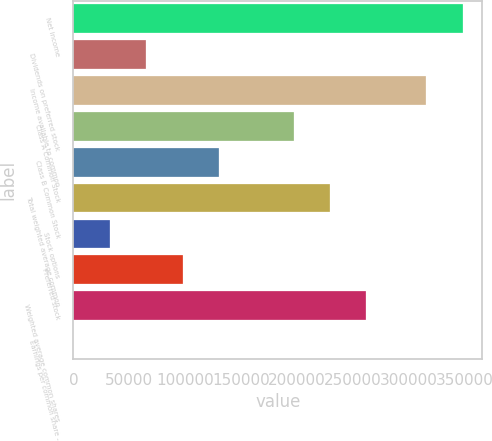Convert chart. <chart><loc_0><loc_0><loc_500><loc_500><bar_chart><fcel>Net income<fcel>Dividends on preferred stock<fcel>Income available to common<fcel>Class A Common Stock<fcel>Class B Common Stock<fcel>Total weighted average common<fcel>Stock options<fcel>Preferred stock<fcel>Weighted average common shares<fcel>Earnings per common share -<nl><fcel>347984<fcel>65053.5<fcel>315458<fcel>196907<fcel>130106<fcel>229433<fcel>32527.4<fcel>97579.5<fcel>261959<fcel>1.36<nl></chart> 